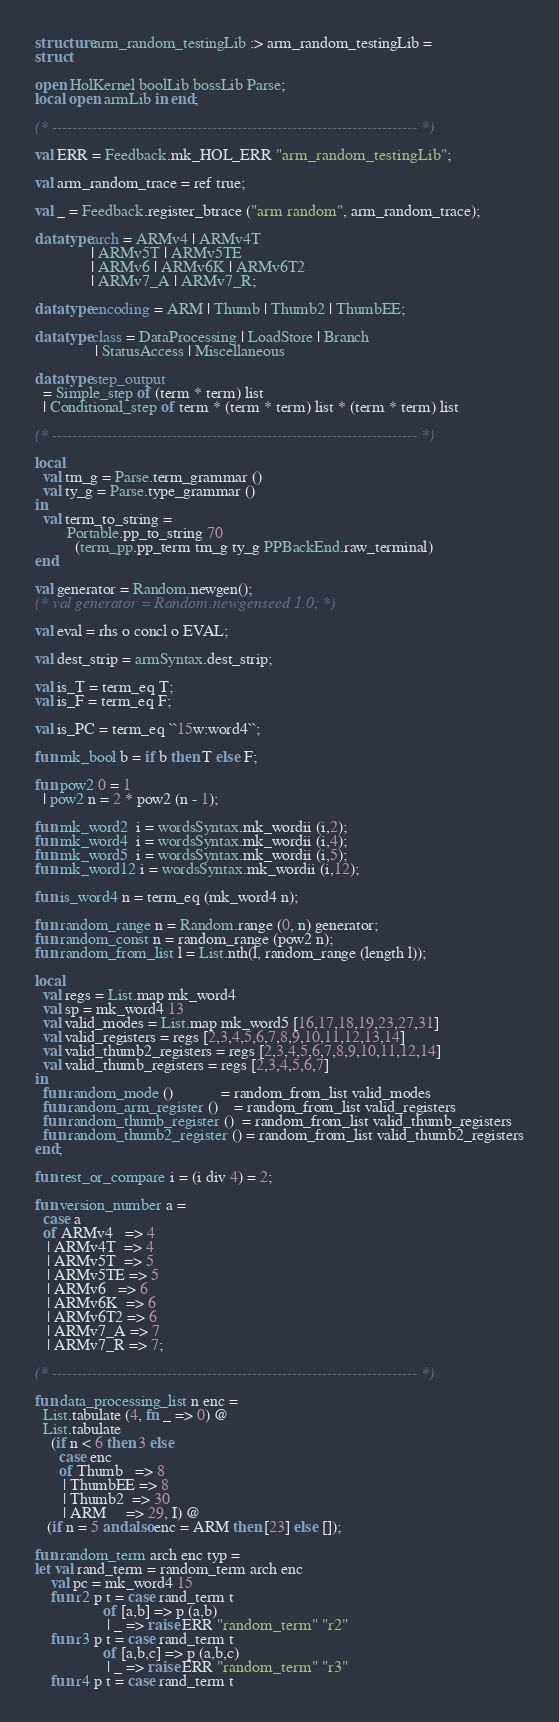Convert code to text. <code><loc_0><loc_0><loc_500><loc_500><_SML_>structure arm_random_testingLib :> arm_random_testingLib =
struct

open HolKernel boolLib bossLib Parse;
local open armLib in end;

(* ------------------------------------------------------------------------- *)

val ERR = Feedback.mk_HOL_ERR "arm_random_testingLib";

val arm_random_trace = ref true;

val _ = Feedback.register_btrace ("arm random", arm_random_trace);

datatype arch = ARMv4 | ARMv4T
              | ARMv5T | ARMv5TE
              | ARMv6 | ARMv6K | ARMv6T2
              | ARMv7_A | ARMv7_R;

datatype encoding = ARM | Thumb | Thumb2 | ThumbEE;

datatype class = DataProcessing | LoadStore | Branch
               | StatusAccess | Miscellaneous

datatype step_output
  = Simple_step of (term * term) list
  | Conditional_step of term * (term * term) list * (term * term) list

(* ------------------------------------------------------------------------- *)

local
  val tm_g = Parse.term_grammar ()
  val ty_g = Parse.type_grammar ()
in
  val term_to_string =
        Portable.pp_to_string 70
          (term_pp.pp_term tm_g ty_g PPBackEnd.raw_terminal)
end

val generator = Random.newgen();
(* val generator = Random.newgenseed 1.0; *)

val eval = rhs o concl o EVAL;

val dest_strip = armSyntax.dest_strip;

val is_T = term_eq T;
val is_F = term_eq F;

val is_PC = term_eq ``15w:word4``;

fun mk_bool b = if b then T else F;

fun pow2 0 = 1
  | pow2 n = 2 * pow2 (n - 1);

fun mk_word2  i = wordsSyntax.mk_wordii (i,2);
fun mk_word4  i = wordsSyntax.mk_wordii (i,4);
fun mk_word5  i = wordsSyntax.mk_wordii (i,5);
fun mk_word12 i = wordsSyntax.mk_wordii (i,12);

fun is_word4 n = term_eq (mk_word4 n);

fun random_range n = Random.range (0, n) generator;
fun random_const n = random_range (pow2 n);
fun random_from_list l = List.nth(l, random_range (length l));

local
  val regs = List.map mk_word4
  val sp = mk_word4 13
  val valid_modes = List.map mk_word5 [16,17,18,19,23,27,31]
  val valid_registers = regs [2,3,4,5,6,7,8,9,10,11,12,13,14]
  val valid_thumb2_registers = regs [2,3,4,5,6,7,8,9,10,11,12,14]
  val valid_thumb_registers = regs [2,3,4,5,6,7]
in
  fun random_mode ()            = random_from_list valid_modes
  fun random_arm_register ()    = random_from_list valid_registers
  fun random_thumb_register ()  = random_from_list valid_thumb_registers
  fun random_thumb2_register () = random_from_list valid_thumb2_registers
end;

fun test_or_compare i = (i div 4) = 2;

fun version_number a =
  case a
  of ARMv4   => 4
   | ARMv4T  => 4
   | ARMv5T  => 5
   | ARMv5TE => 5
   | ARMv6   => 6
   | ARMv6K  => 6
   | ARMv6T2 => 6
   | ARMv7_A => 7
   | ARMv7_R => 7;

(* ------------------------------------------------------------------------- *)

fun data_processing_list n enc =
  List.tabulate (4, fn _ => 0) @
  List.tabulate
    (if n < 6 then 3 else
      case enc
      of Thumb   => 8
       | ThumbEE => 8
       | Thumb2  => 30
       | ARM     => 29, I) @
   (if n = 5 andalso enc = ARM then [23] else []);

fun random_term arch enc typ =
let val rand_term = random_term arch enc
    val pc = mk_word4 15
    fun r2 p t = case rand_term t
                 of [a,b] => p (a,b)
                  | _ => raise ERR "random_term" "r2"
    fun r3 p t = case rand_term t
                 of [a,b,c] => p (a,b,c)
                  | _ => raise ERR "random_term" "r3"
    fun r4 p t = case rand_term t</code> 